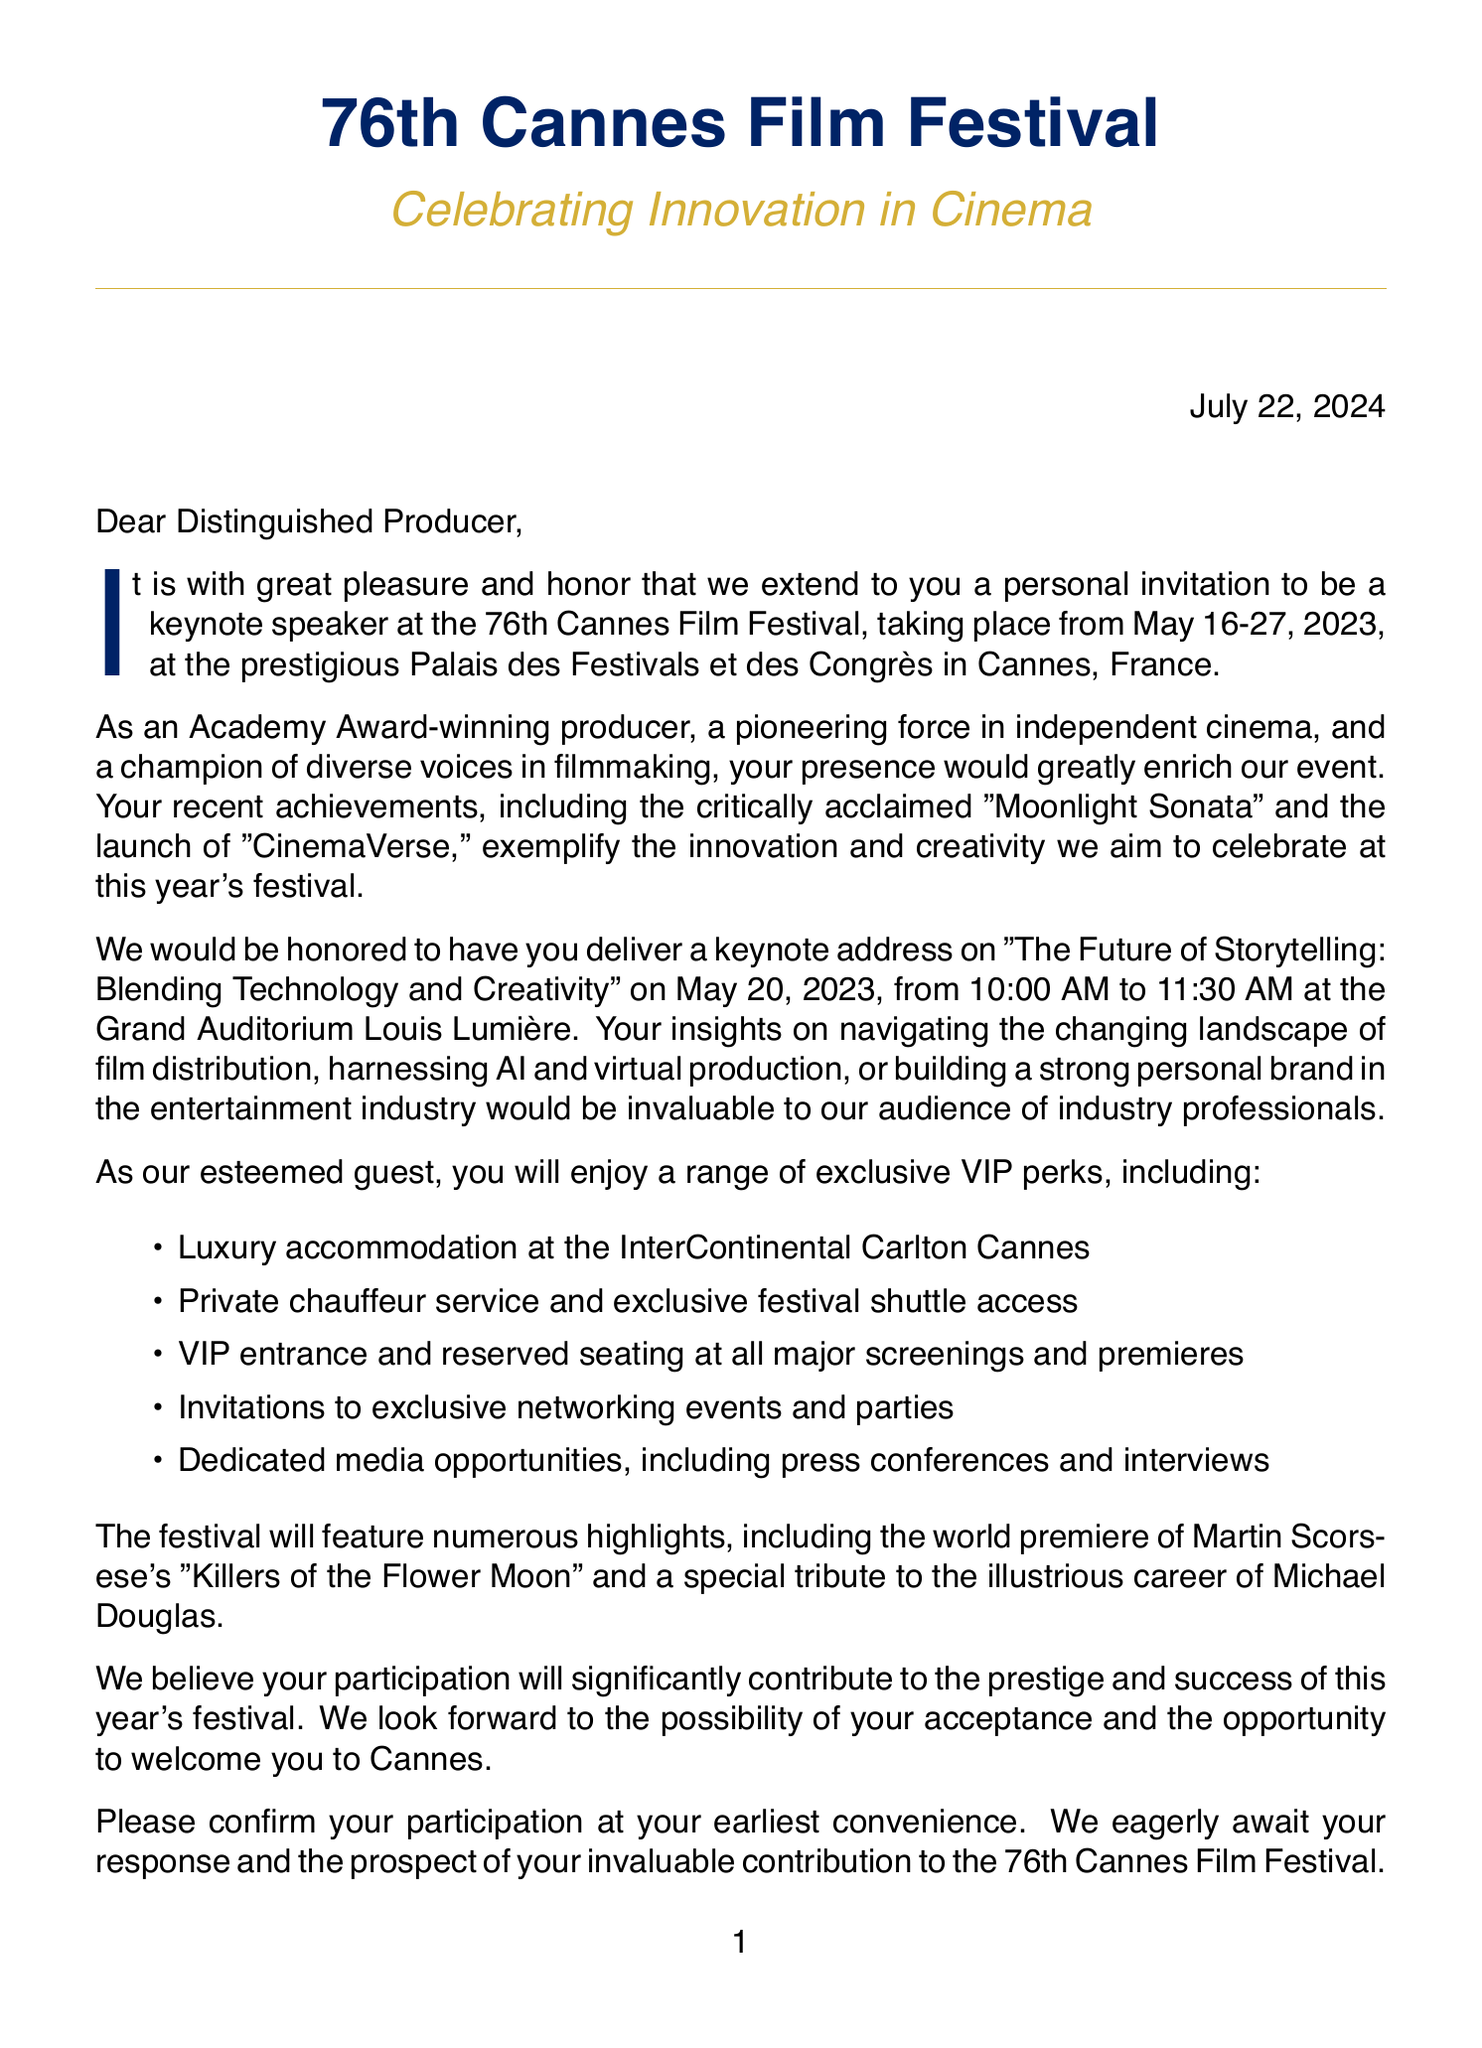What is the date of the 76th Cannes Film Festival? The date is specified in the document as May 16-27, 2023.
Answer: May 16-27, 2023 What is the theme of the festival? The theme is stated in the document, which highlights the focus of this event.
Answer: Celebrating Innovation in Cinema What is the title of the keynote session? The title is explicitly mentioned in the keynote session details.
Answer: The Future of Storytelling: Blending Technology and Creativity What hotel will the VIP accommodation be at? The document lists the hotel provided for accommodation perks.
Answer: InterContinental Carlton Cannes What kind of transportation will be provided to the keynote speaker? The transportation details are outlined in the VIP perks section.
Answer: Private chauffeur-driven Mercedes-Benz S-Class How long is the keynote address scheduled to last? The duration of the keynote session is detailed in the speaking engagement section.
Answer: 45 minutes What significant film will premiere at the festival? The document includes a notable premiere highlight.
Answer: Martin Scorsese's 'Killers of the Flower Moon' What is the expected attendance at the event? The document gives a specific number representing the expected audience.
Answer: 2000 What exclusive party is the keynote speaker invited to? The document lists exclusive access perks, including specific events for VIP guests.
Answer: Chopard party Who is the President of the Cannes Film Festival? This information is provided in the closing signature of the letter.
Answer: Iris Knobloch 